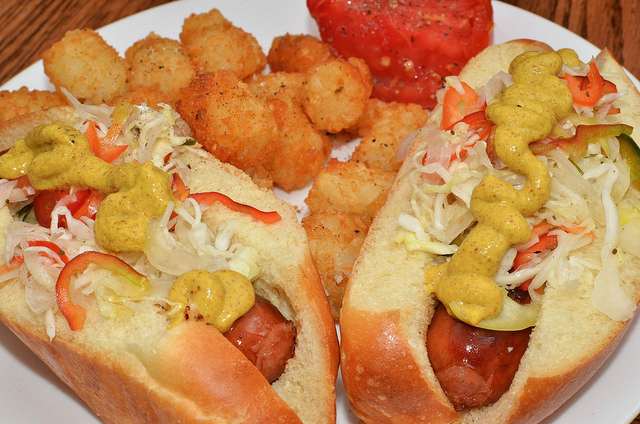<image>What is the pattern on the plate? I am not sure about the pattern on the plate. It could possibly be solid, striped, or have no pattern at all. What is the pattern on the plate? I don't know what is the pattern on the plate. It can be seen as plain, solid, solid white, v, none, circular, mismatched, striped, or solid. 